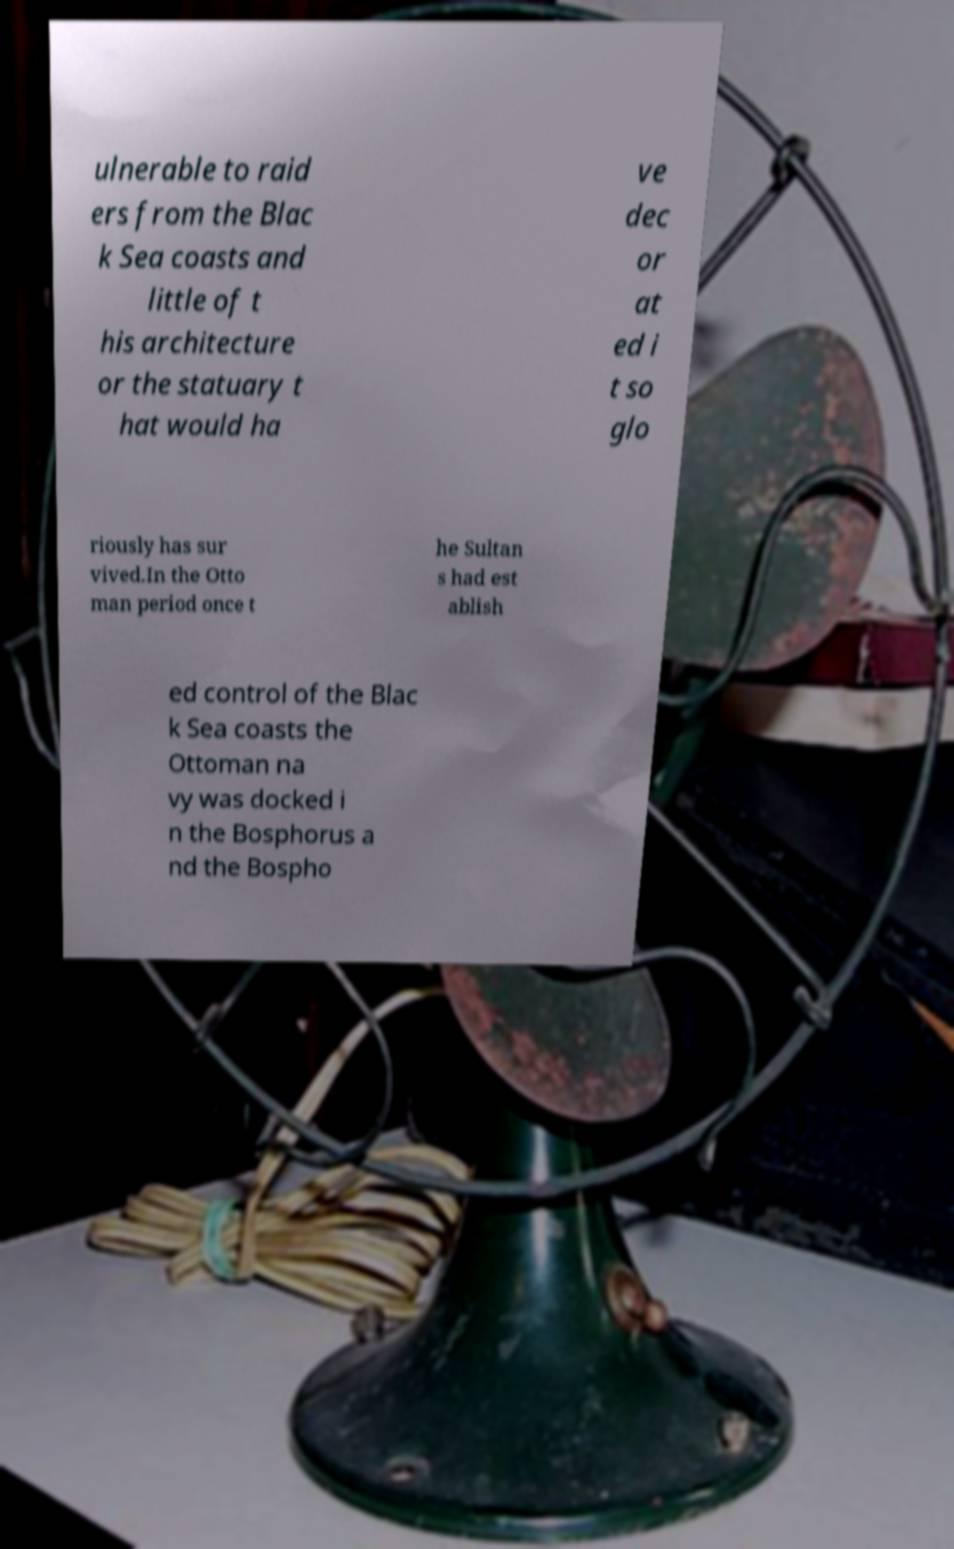There's text embedded in this image that I need extracted. Can you transcribe it verbatim? ulnerable to raid ers from the Blac k Sea coasts and little of t his architecture or the statuary t hat would ha ve dec or at ed i t so glo riously has sur vived.In the Otto man period once t he Sultan s had est ablish ed control of the Blac k Sea coasts the Ottoman na vy was docked i n the Bosphorus a nd the Bospho 